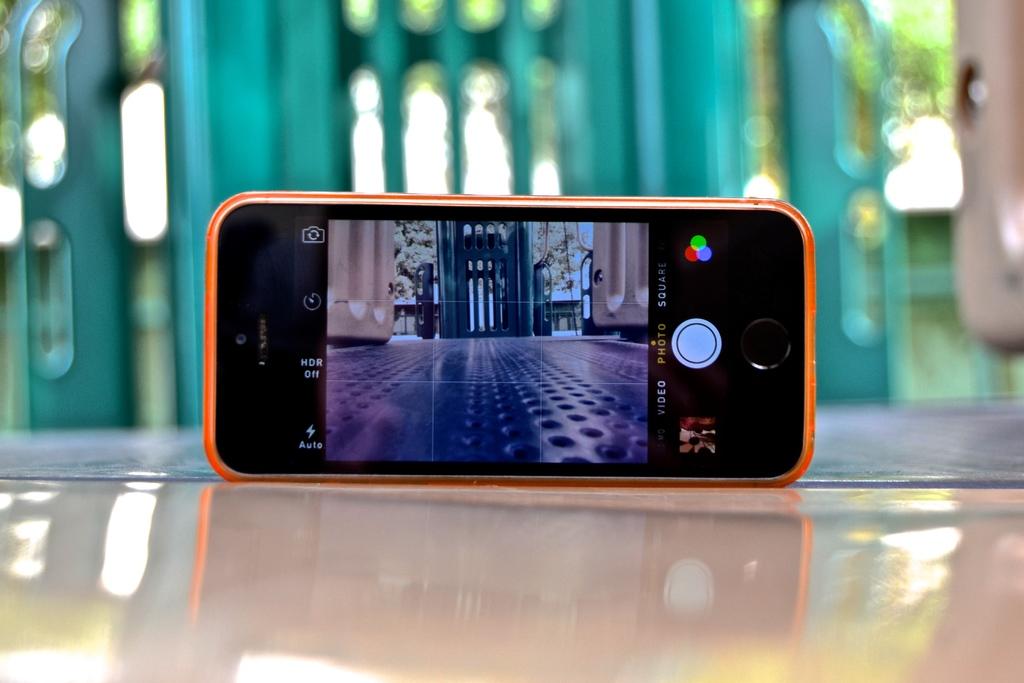Are they in photomode?
Your response must be concise. Yes. Is hdr on?
Keep it short and to the point. No. 